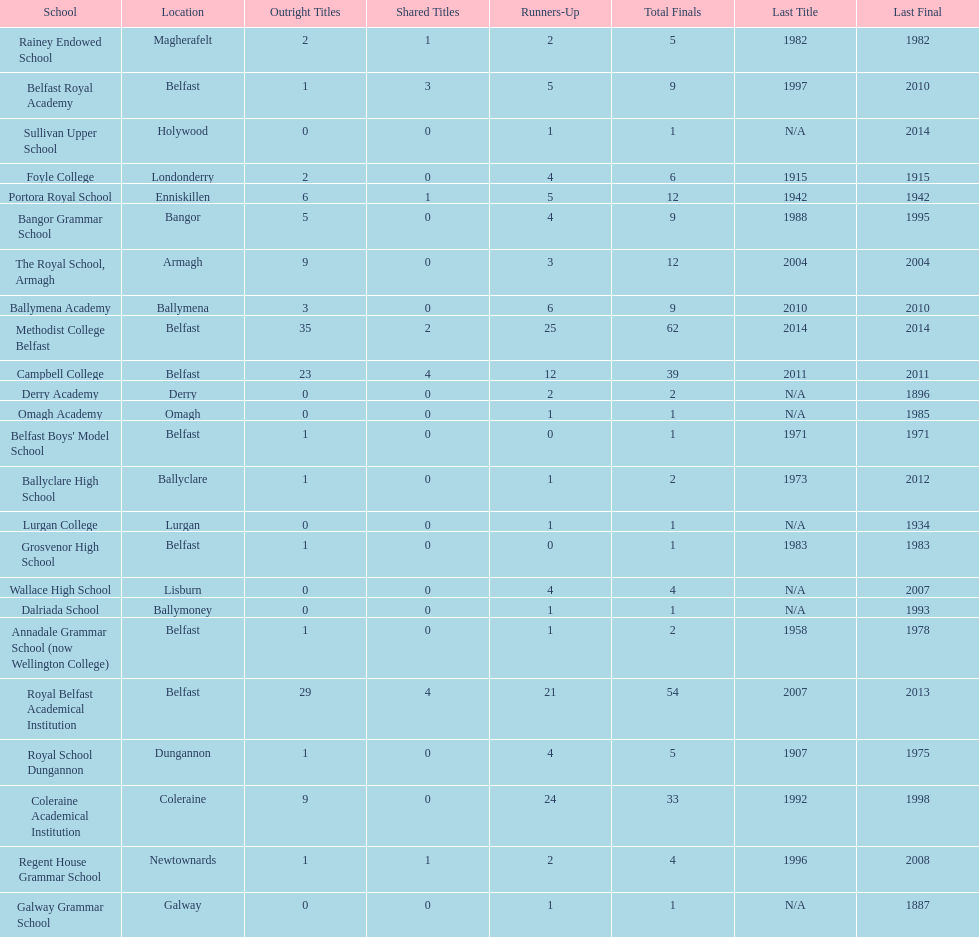Which two schools each had twelve total finals? The Royal School, Armagh, Portora Royal School. 